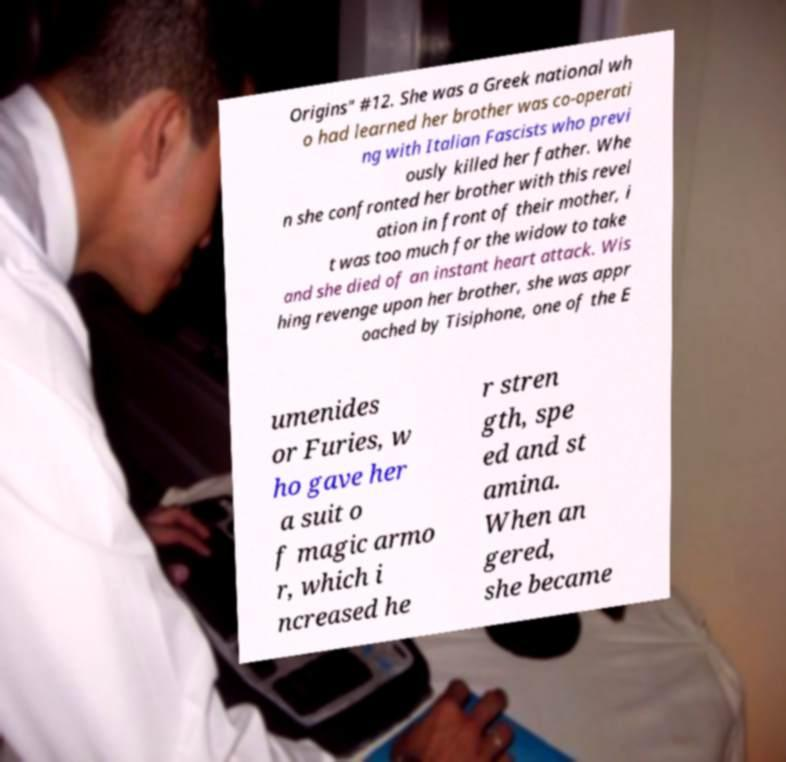Could you extract and type out the text from this image? Origins" #12. She was a Greek national wh o had learned her brother was co-operati ng with Italian Fascists who previ ously killed her father. Whe n she confronted her brother with this revel ation in front of their mother, i t was too much for the widow to take and she died of an instant heart attack. Wis hing revenge upon her brother, she was appr oached by Tisiphone, one of the E umenides or Furies, w ho gave her a suit o f magic armo r, which i ncreased he r stren gth, spe ed and st amina. When an gered, she became 